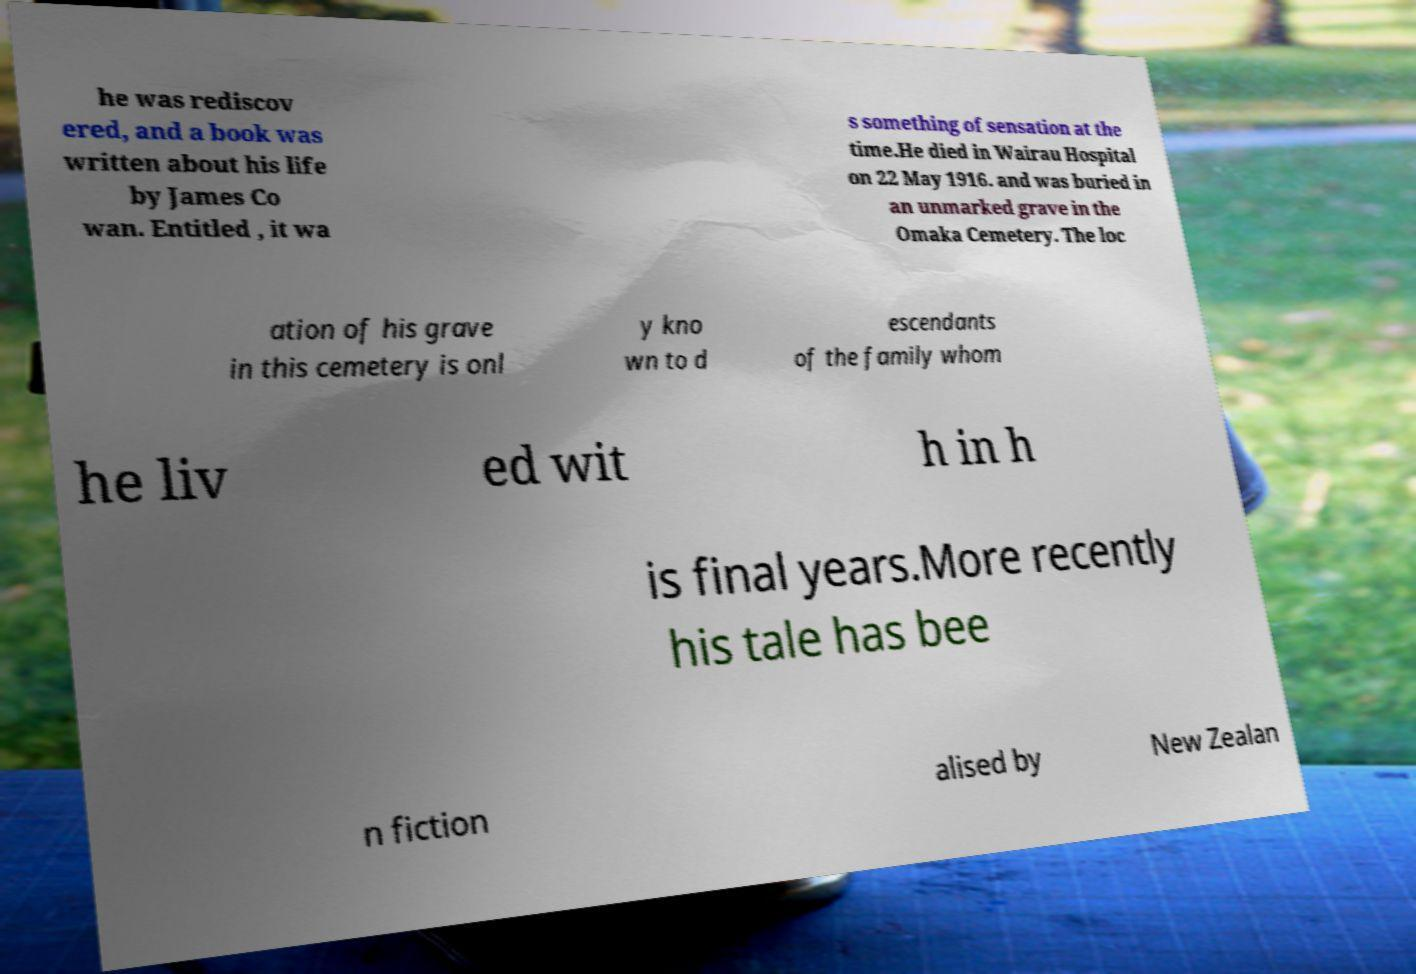Please identify and transcribe the text found in this image. he was rediscov ered, and a book was written about his life by James Co wan. Entitled , it wa s something of sensation at the time.He died in Wairau Hospital on 22 May 1916. and was buried in an unmarked grave in the Omaka Cemetery. The loc ation of his grave in this cemetery is onl y kno wn to d escendants of the family whom he liv ed wit h in h is final years.More recently his tale has bee n fiction alised by New Zealan 